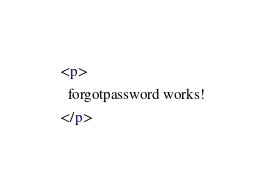<code> <loc_0><loc_0><loc_500><loc_500><_HTML_><p>
  forgotpassword works!
</p>
</code> 